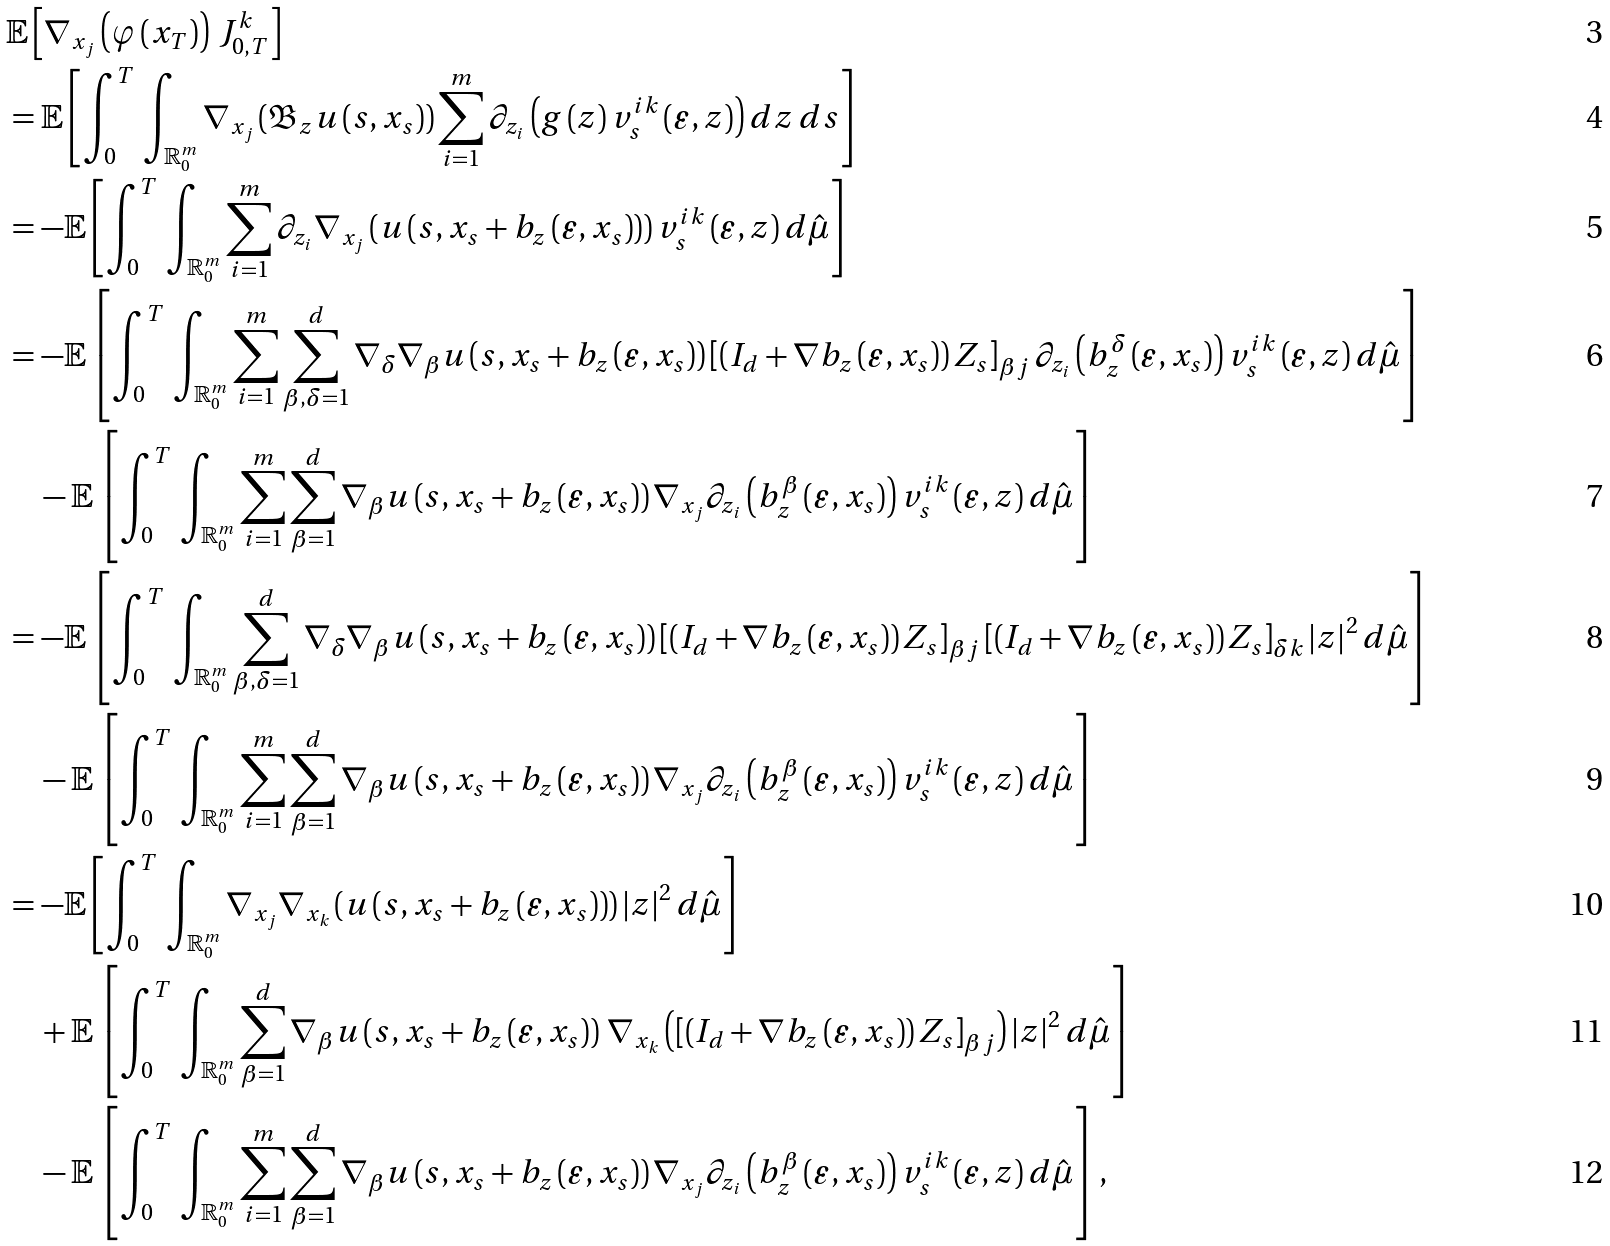Convert formula to latex. <formula><loc_0><loc_0><loc_500><loc_500>& \mathbb { E } \left [ \nabla _ { x _ { j } } \left ( \varphi \left ( x _ { T } \right ) \right ) \, J _ { 0 , T } ^ { k } \right ] \\ & = \mathbb { E } \left [ \int _ { 0 } ^ { T } \, \int _ { \mathbb { R } _ { 0 } ^ { m } } \nabla _ { x _ { j } } \left ( \mathfrak { B } _ { z } u \left ( s , x _ { s } \right ) \right ) \sum _ { i = 1 } ^ { m } \partial _ { z _ { i } } \left ( g \left ( z \right ) v _ { s } ^ { i k } \left ( \varepsilon , z \right ) \right ) d z \, d s \right ] \\ & = - \mathbb { E } \left [ \int _ { 0 } ^ { T } \, \int _ { \mathbb { R } _ { 0 } ^ { m } } \sum _ { i = 1 } ^ { m } \partial _ { z _ { i } } \nabla _ { x _ { j } } \left ( u \left ( s , x _ { s } + b _ { z } \left ( \varepsilon , x _ { s } \right ) \right ) \right ) v _ { s } ^ { i k } \left ( \varepsilon , z \right ) d \hat { \mu } \right ] \\ & = - \mathbb { E } \left [ \int _ { 0 } ^ { T } \, \int _ { \mathbb { R } _ { 0 } ^ { m } } \sum _ { i = 1 } ^ { m } \sum _ { \beta , \delta = 1 } ^ { d } \nabla _ { \delta } \nabla _ { \beta } u \left ( s , x _ { s } + b _ { z } \left ( \varepsilon , x _ { s } \right ) \right ) \left [ \left ( I _ { d } + \nabla b _ { z } \left ( \varepsilon , x _ { s } \right ) \right ) Z _ { s } \right ] _ { \beta j } \partial _ { z _ { i } } \left ( b _ { z } ^ { \delta } \left ( \varepsilon , x _ { s } \right ) \right ) v _ { s } ^ { i k } \left ( \varepsilon , z \right ) d \hat { \mu } \right ] \\ & \quad - \mathbb { E } \left [ \int _ { 0 } ^ { T } \, \int _ { \mathbb { R } _ { 0 } ^ { m } } \sum _ { i = 1 } ^ { m } \sum _ { \beta = 1 } ^ { d } \nabla _ { \beta } u \left ( s , x _ { s } + b _ { z } \left ( \varepsilon , x _ { s } \right ) \right ) \nabla _ { x _ { j } } \partial _ { z _ { i } } \left ( b _ { z } ^ { \beta } \left ( \varepsilon , x _ { s } \right ) \right ) v _ { s } ^ { i k } \left ( \varepsilon , z \right ) d \hat { \mu } \right ] \\ & = - \mathbb { E } \left [ \int _ { 0 } ^ { T } \, \int _ { \mathbb { R } _ { 0 } ^ { m } } \sum _ { \beta , \delta = 1 } ^ { d } \nabla _ { \delta } \nabla _ { \beta } u \left ( s , x _ { s } + b _ { z } \left ( \varepsilon , x _ { s } \right ) \right ) \left [ \left ( I _ { d } + \nabla b _ { z } \left ( \varepsilon , x _ { s } \right ) \right ) Z _ { s } \right ] _ { \beta j } \left [ \left ( I _ { d } + \nabla b _ { z } \left ( \varepsilon , x _ { s } \right ) \right ) Z _ { s } \right ] _ { \delta k } \left | z \right | ^ { 2 } d \hat { \mu } \right ] \\ & \quad - \mathbb { E } \left [ \int _ { 0 } ^ { T } \, \int _ { \mathbb { R } _ { 0 } ^ { m } } \sum _ { i = 1 } ^ { m } \sum _ { \beta = 1 } ^ { d } \nabla _ { \beta } u \left ( s , x _ { s } + b _ { z } \left ( \varepsilon , x _ { s } \right ) \right ) \nabla _ { x _ { j } } \partial _ { z _ { i } } \left ( b _ { z } ^ { \beta } \left ( \varepsilon , x _ { s } \right ) \right ) v _ { s } ^ { i k } \left ( \varepsilon , z \right ) d \hat { \mu } \right ] \\ & = - \mathbb { E } \left [ \int _ { 0 } ^ { T } \, \int _ { \mathbb { R } _ { 0 } ^ { m } } \nabla _ { x _ { j } } \nabla _ { x _ { k } } \left ( u \left ( s , x _ { s } + b _ { z } \left ( \varepsilon , x _ { s } \right ) \right ) \right ) \left | z \right | ^ { 2 } d \hat { \mu } \right ] \\ & \quad + \mathbb { E } \left [ \int _ { 0 } ^ { T } \, \int _ { \mathbb { R } _ { 0 } ^ { m } } \sum _ { \beta = 1 } ^ { d } \nabla _ { \beta } u \left ( s , x _ { s } + b _ { z } \left ( \varepsilon , x _ { s } \right ) \right ) \, \nabla _ { x _ { k } } \left ( \left [ \left ( I _ { d } + \nabla b _ { z } \left ( \varepsilon , x _ { s } \right ) \right ) Z _ { s } \right ] _ { \beta j } \right ) \left | z \right | ^ { 2 } d \hat { \mu } \right ] \\ & \quad - \mathbb { E } \left [ \int _ { 0 } ^ { T } \, \int _ { \mathbb { R } _ { 0 } ^ { m } } \sum _ { i = 1 } ^ { m } \sum _ { \beta = 1 } ^ { d } \nabla _ { \beta } u \left ( s , x _ { s } + b _ { z } \left ( \varepsilon , x _ { s } \right ) \right ) \nabla _ { x _ { j } } \partial _ { z _ { i } } \left ( b _ { z } ^ { \beta } \left ( \varepsilon , x _ { s } \right ) \right ) v _ { s } ^ { i k } \left ( \varepsilon , z \right ) d \hat { \mu } \right ] ,</formula> 